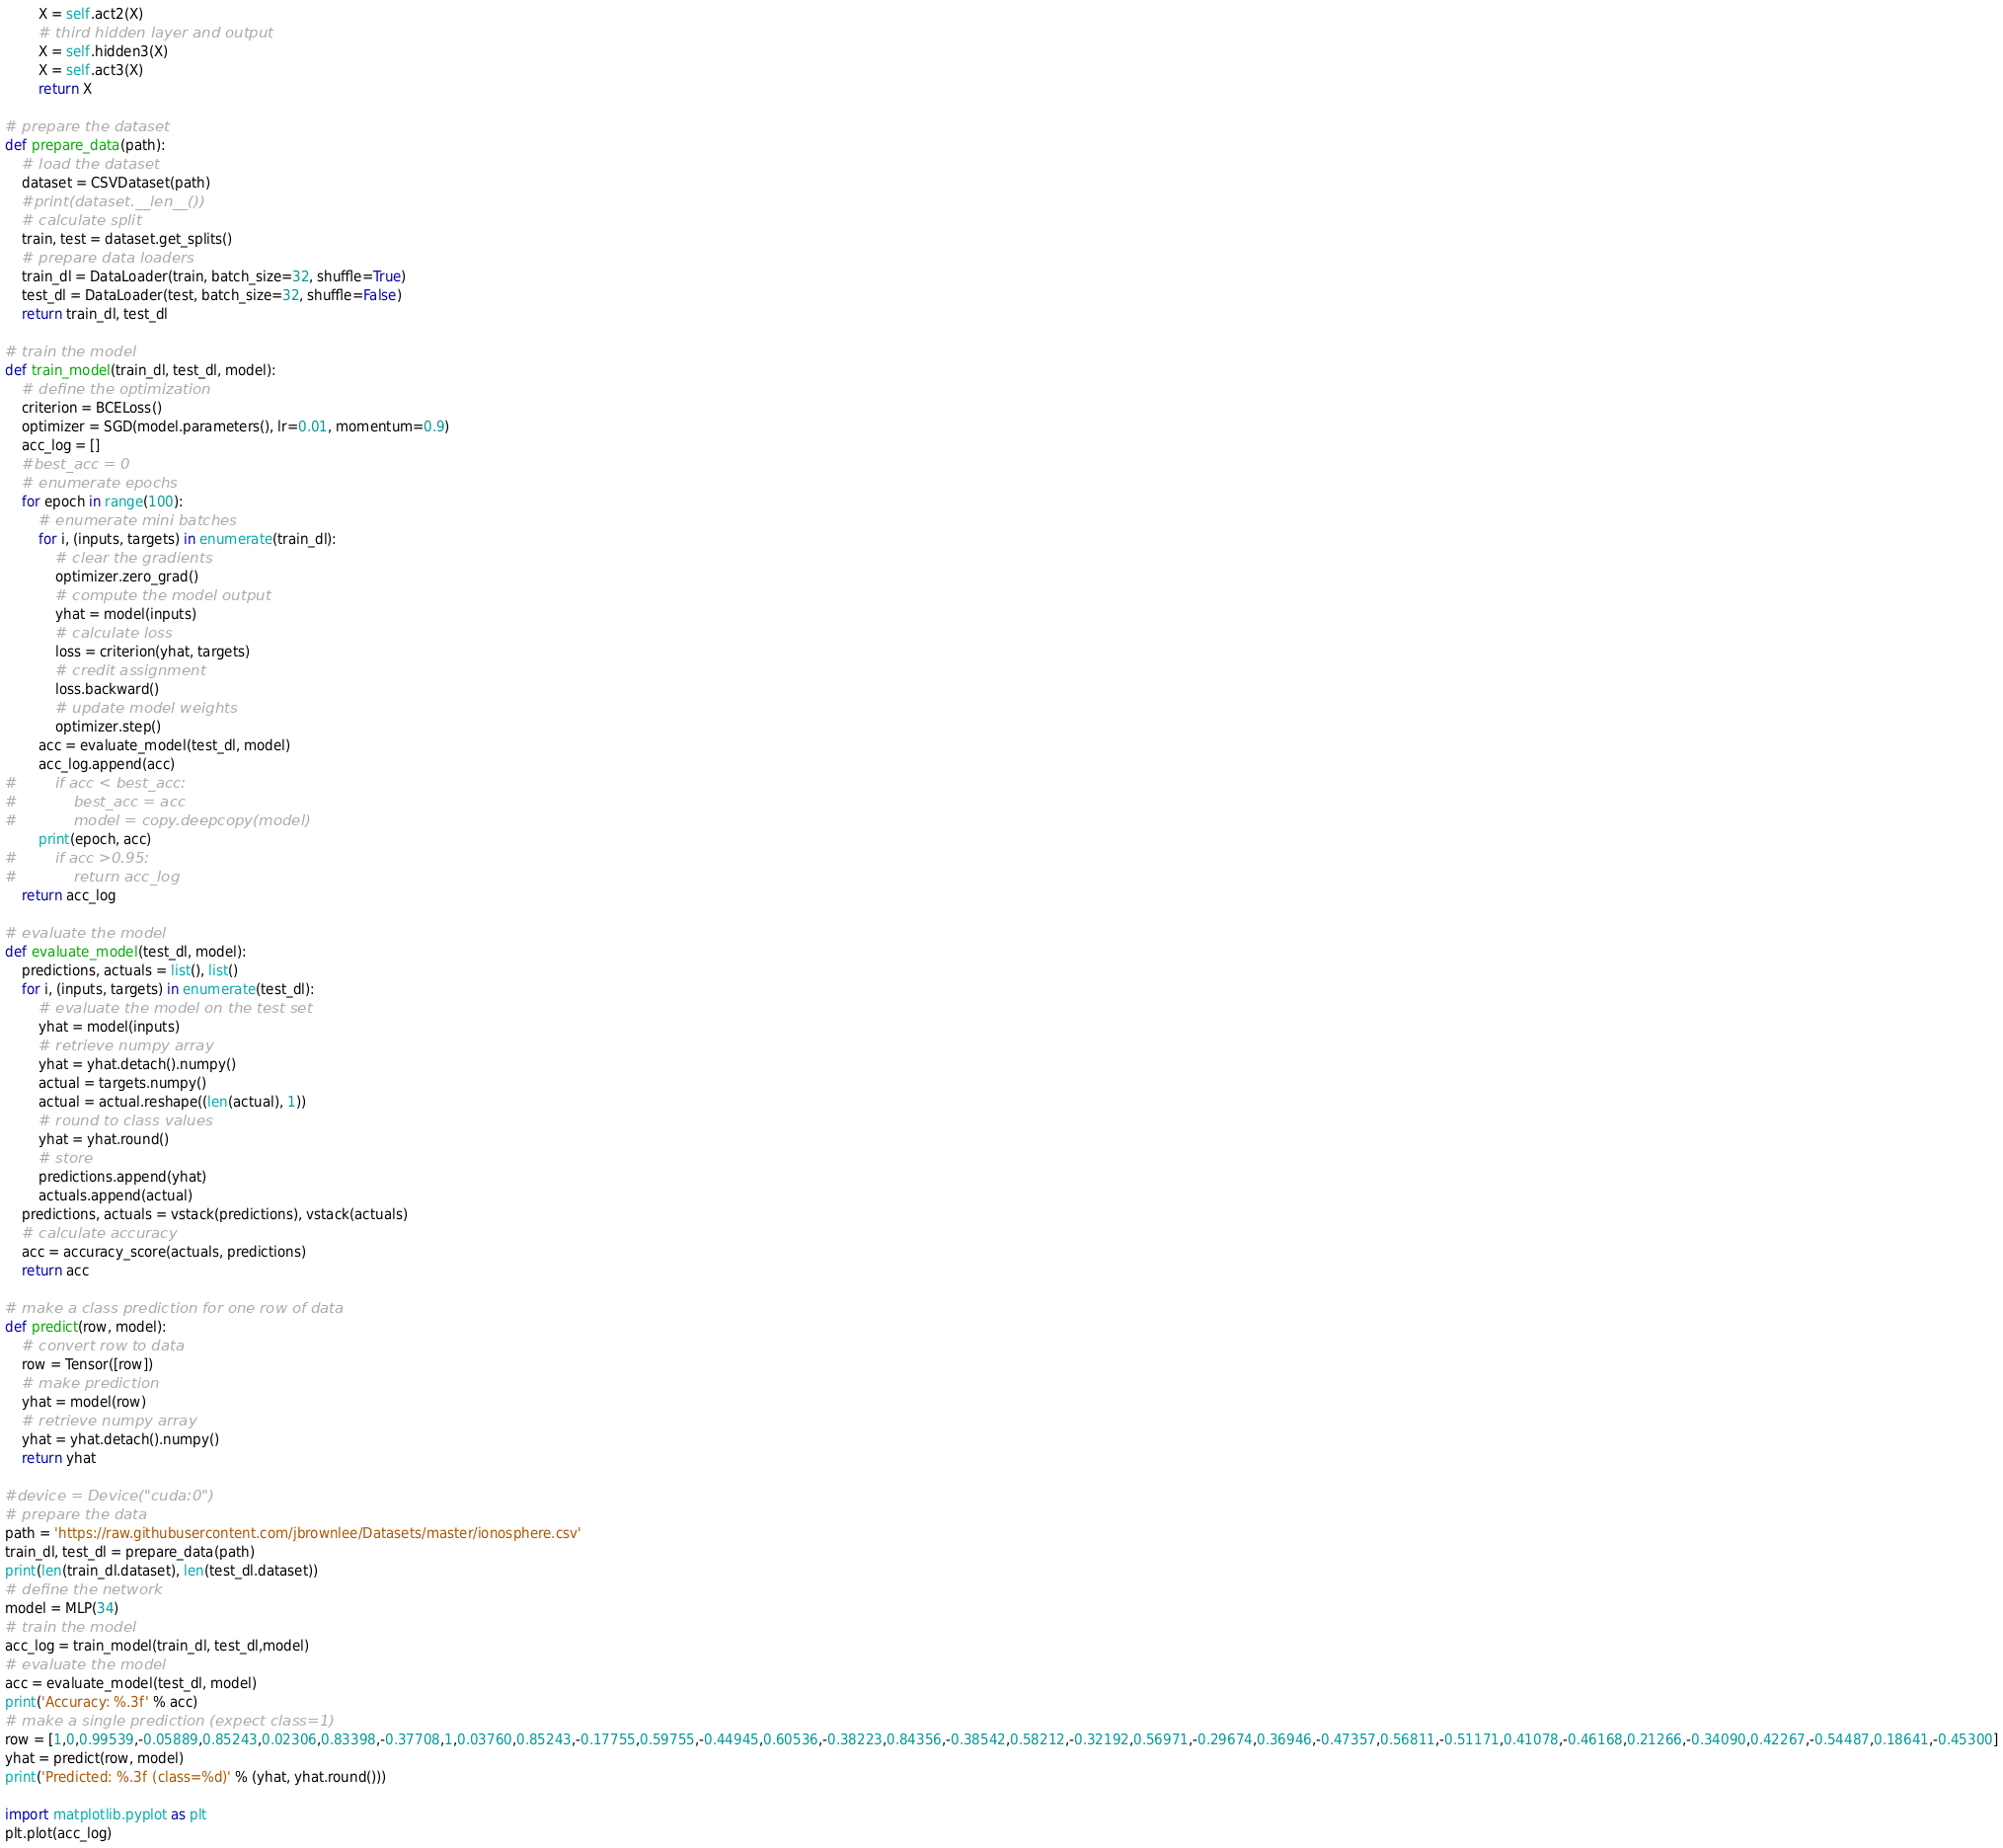Convert code to text. <code><loc_0><loc_0><loc_500><loc_500><_Python_>        X = self.act2(X)
        # third hidden layer and output
        X = self.hidden3(X)
        X = self.act3(X)
        return X

# prepare the dataset
def prepare_data(path):
    # load the dataset
    dataset = CSVDataset(path)
    #print(dataset.__len__())
    # calculate split
    train, test = dataset.get_splits()
    # prepare data loaders
    train_dl = DataLoader(train, batch_size=32, shuffle=True)
    test_dl = DataLoader(test, batch_size=32, shuffle=False)
    return train_dl, test_dl

# train the model
def train_model(train_dl, test_dl, model):
    # define the optimization
    criterion = BCELoss()
    optimizer = SGD(model.parameters(), lr=0.01, momentum=0.9)
    acc_log = []
    #best_acc = 0
    # enumerate epochs
    for epoch in range(100):
        # enumerate mini batches
        for i, (inputs, targets) in enumerate(train_dl):
            # clear the gradients
            optimizer.zero_grad()
            # compute the model output
            yhat = model(inputs)
            # calculate loss
            loss = criterion(yhat, targets)
            # credit assignment
            loss.backward()
            # update model weights
            optimizer.step()
        acc = evaluate_model(test_dl, model)
        acc_log.append(acc)
#        if acc < best_acc:
#            best_acc = acc
#            model = copy.deepcopy(model)
        print(epoch, acc)
#        if acc >0.95:
#            return acc_log
    return acc_log

# evaluate the model
def evaluate_model(test_dl, model):
    predictions, actuals = list(), list()
    for i, (inputs, targets) in enumerate(test_dl):
        # evaluate the model on the test set
        yhat = model(inputs)
        # retrieve numpy array
        yhat = yhat.detach().numpy()
        actual = targets.numpy()
        actual = actual.reshape((len(actual), 1))
        # round to class values
        yhat = yhat.round()
        # store
        predictions.append(yhat)
        actuals.append(actual)
    predictions, actuals = vstack(predictions), vstack(actuals)
    # calculate accuracy
    acc = accuracy_score(actuals, predictions)
    return acc

# make a class prediction for one row of data
def predict(row, model):
    # convert row to data
    row = Tensor([row])
    # make prediction
    yhat = model(row)
    # retrieve numpy array
    yhat = yhat.detach().numpy()
    return yhat

#device = Device("cuda:0")
# prepare the data
path = 'https://raw.githubusercontent.com/jbrownlee/Datasets/master/ionosphere.csv'
train_dl, test_dl = prepare_data(path)
print(len(train_dl.dataset), len(test_dl.dataset))
# define the network
model = MLP(34)
# train the model
acc_log = train_model(train_dl, test_dl,model)
# evaluate the model
acc = evaluate_model(test_dl, model)
print('Accuracy: %.3f' % acc)
# make a single prediction (expect class=1)
row = [1,0,0.99539,-0.05889,0.85243,0.02306,0.83398,-0.37708,1,0.03760,0.85243,-0.17755,0.59755,-0.44945,0.60536,-0.38223,0.84356,-0.38542,0.58212,-0.32192,0.56971,-0.29674,0.36946,-0.47357,0.56811,-0.51171,0.41078,-0.46168,0.21266,-0.34090,0.42267,-0.54487,0.18641,-0.45300]
yhat = predict(row, model)
print('Predicted: %.3f (class=%d)' % (yhat, yhat.round()))

import matplotlib.pyplot as plt
plt.plot(acc_log)
</code> 